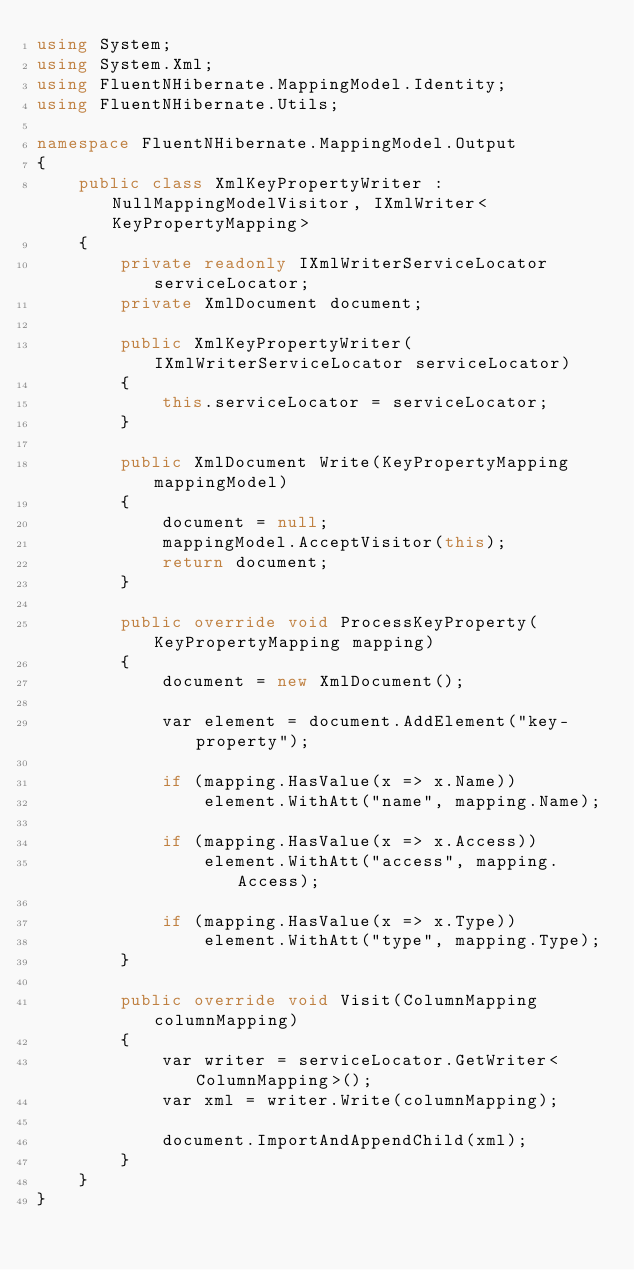<code> <loc_0><loc_0><loc_500><loc_500><_C#_>using System;
using System.Xml;
using FluentNHibernate.MappingModel.Identity;
using FluentNHibernate.Utils;

namespace FluentNHibernate.MappingModel.Output
{
    public class XmlKeyPropertyWriter : NullMappingModelVisitor, IXmlWriter<KeyPropertyMapping>
    {
        private readonly IXmlWriterServiceLocator serviceLocator;
        private XmlDocument document;

        public XmlKeyPropertyWriter(IXmlWriterServiceLocator serviceLocator)
        {
            this.serviceLocator = serviceLocator;
        }

        public XmlDocument Write(KeyPropertyMapping mappingModel)
        {
            document = null;
            mappingModel.AcceptVisitor(this);
            return document;
        }

        public override void ProcessKeyProperty(KeyPropertyMapping mapping)
        {
            document = new XmlDocument();

            var element = document.AddElement("key-property");

            if (mapping.HasValue(x => x.Name))
                element.WithAtt("name", mapping.Name);

            if (mapping.HasValue(x => x.Access))
                element.WithAtt("access", mapping.Access);

            if (mapping.HasValue(x => x.Type))
                element.WithAtt("type", mapping.Type);
        }

        public override void Visit(ColumnMapping columnMapping)
        {
            var writer = serviceLocator.GetWriter<ColumnMapping>();
            var xml = writer.Write(columnMapping);

            document.ImportAndAppendChild(xml);
        }
    }
}</code> 